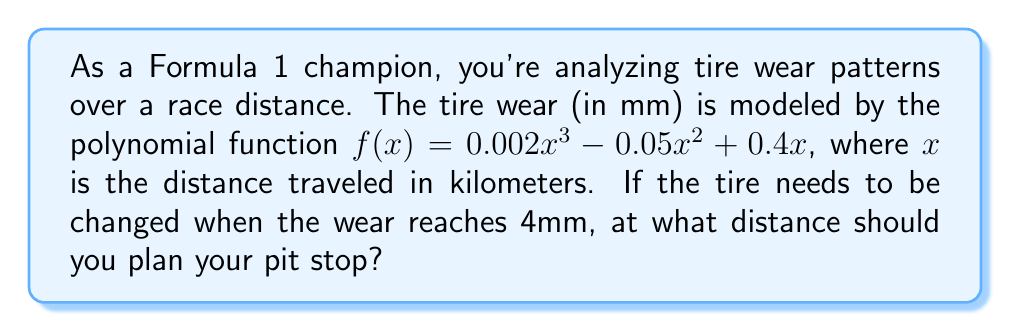Show me your answer to this math problem. To solve this problem, we need to find the value of $x$ where $f(x) = 4$. Let's approach this step-by-step:

1) Set up the equation:
   $0.002x^3 - 0.05x^2 + 0.4x = 4$

2) Rearrange to standard form:
   $0.002x^3 - 0.05x^2 + 0.4x - 4 = 0$

3) This is a cubic equation. While it can be solved algebraically, it's complex. In a race scenario, we'd typically use numerical methods or graphing calculators. Let's use the Newton-Raphson method.

4) The Newton-Raphson formula is:
   $x_{n+1} = x_n - \frac{f(x_n)}{f'(x_n)}$

5) We need $f'(x)$:
   $f'(x) = 0.006x^2 - 0.1x + 0.4$

6) Let's start with $x_0 = 20$ (an educated guess based on typical pit stop distances):

   $x_1 = 20 - \frac{0.002(20^3) - 0.05(20^2) + 0.4(20) - 4}{0.006(20^2) - 0.1(20) + 0.4} \approx 22.96$

   $x_2 = 22.96 - \frac{0.002(22.96^3) - 0.05(22.96^2) + 0.4(22.96) - 4}{0.006(22.96^2) - 0.1(22.96) + 0.4} \approx 23.38$

   $x_3 = 23.38 - \frac{0.002(23.38^3) - 0.05(23.38^2) + 0.4(23.38) - 4}{0.006(23.38^2) - 0.1(23.38) + 0.4} \approx 23.39$

7) The solution converges to approximately 23.39 km.
Answer: 23.39 km 